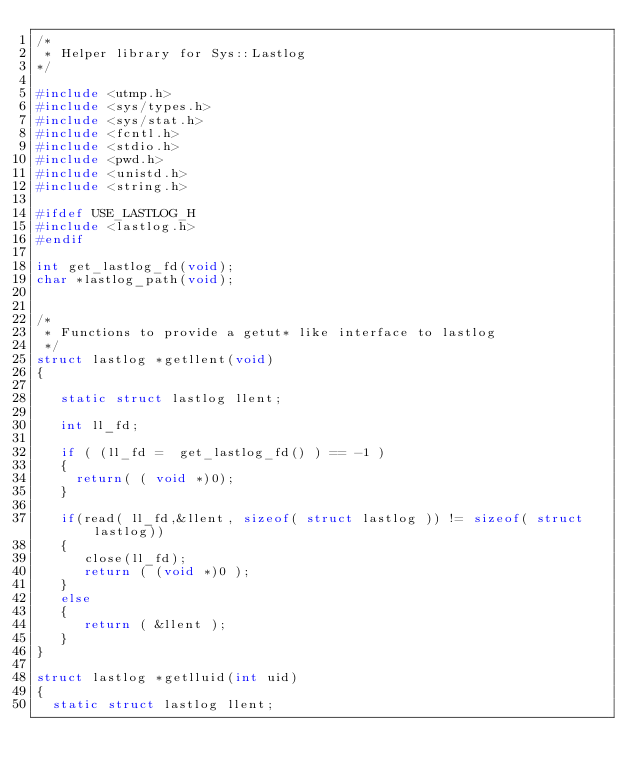<code> <loc_0><loc_0><loc_500><loc_500><_C_>/*
 * Helper library for Sys::Lastlog
*/

#include <utmp.h>
#include <sys/types.h>
#include <sys/stat.h>
#include <fcntl.h>
#include <stdio.h>
#include <pwd.h>
#include <unistd.h>
#include <string.h>

#ifdef USE_LASTLOG_H
#include <lastlog.h>
#endif

int get_lastlog_fd(void);
char *lastlog_path(void);


/* 
 * Functions to provide a getut* like interface to lastlog
 */
struct lastlog *getllent(void)
{

   static struct lastlog llent;

   int ll_fd;

   if ( (ll_fd =  get_lastlog_fd() ) == -1 )
   {
     return( ( void *)0);
   }

   if(read( ll_fd,&llent, sizeof( struct lastlog )) != sizeof( struct lastlog))
   {
      close(ll_fd);
      return ( (void *)0 );
   }
   else
   {
      return ( &llent );
   }
}

struct lastlog *getlluid(int uid)
{
  static struct lastlog llent;</code> 